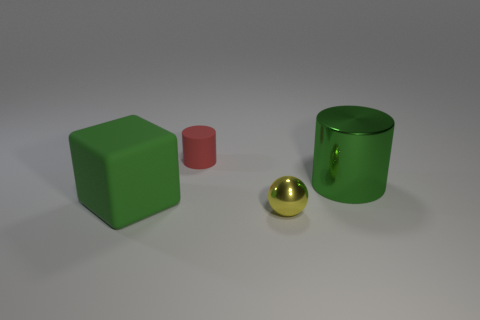Does the matte thing behind the block have the same shape as the green metallic thing?
Offer a very short reply. Yes. Is the large green metal object the same shape as the tiny rubber object?
Make the answer very short. Yes. What number of shiny objects are either large green cubes or small green balls?
Give a very brief answer. 0. What is the material of the cylinder that is the same color as the big matte block?
Offer a terse response. Metal. Does the yellow ball have the same size as the green rubber object?
Give a very brief answer. No. What number of things are large green matte things or big objects that are behind the matte cube?
Your answer should be compact. 2. What material is the red cylinder that is the same size as the yellow thing?
Give a very brief answer. Rubber. The object that is in front of the large green metallic object and on the right side of the small red rubber thing is made of what material?
Your answer should be very brief. Metal. Are there any metal cylinders in front of the green object that is to the right of the large block?
Offer a terse response. No. There is a thing that is both behind the green matte thing and to the left of the shiny ball; what is its size?
Make the answer very short. Small. 